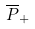Convert formula to latex. <formula><loc_0><loc_0><loc_500><loc_500>\overline { P } _ { + }</formula> 